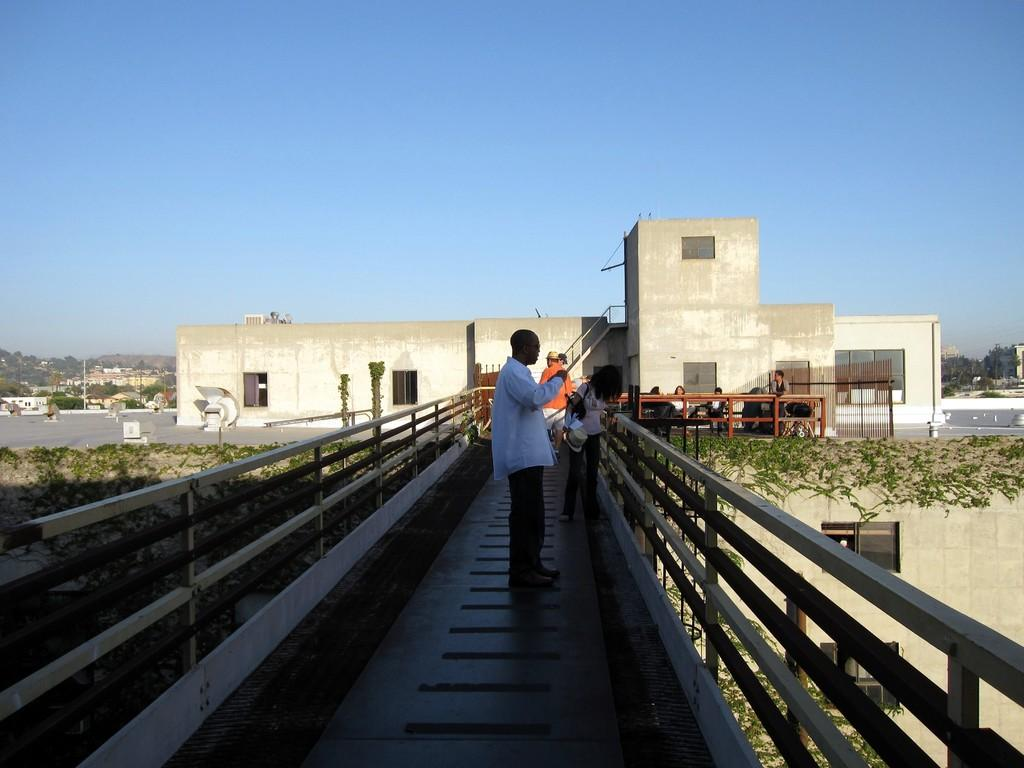Who or what can be seen in the image? There are people in the image. What can be seen in the distance behind the people? There are buildings, trees, and the sky visible in the background of the image. What type of plough is being used by the people in the image? There is no plough present in the image; it features people and background elements. 